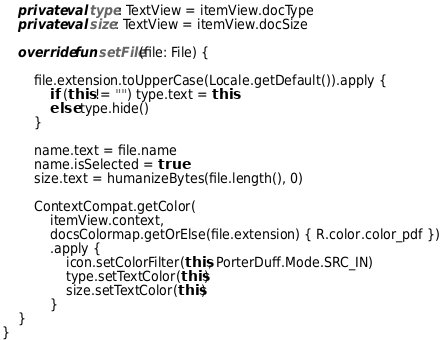Convert code to text. <code><loc_0><loc_0><loc_500><loc_500><_Kotlin_>    private val type: TextView = itemView.docType
    private val size: TextView = itemView.docSize

    override fun setFile(file: File) {

        file.extension.toUpperCase(Locale.getDefault()).apply {
            if (this != "") type.text = this
            else type.hide()
        }

        name.text = file.name
        name.isSelected = true
        size.text = humanizeBytes(file.length(), 0)

        ContextCompat.getColor(
            itemView.context,
            docsColormap.getOrElse(file.extension) { R.color.color_pdf })
            .apply {
                icon.setColorFilter(this, PorterDuff.Mode.SRC_IN)
                type.setTextColor(this)
                size.setTextColor(this)
            }
    }
}</code> 